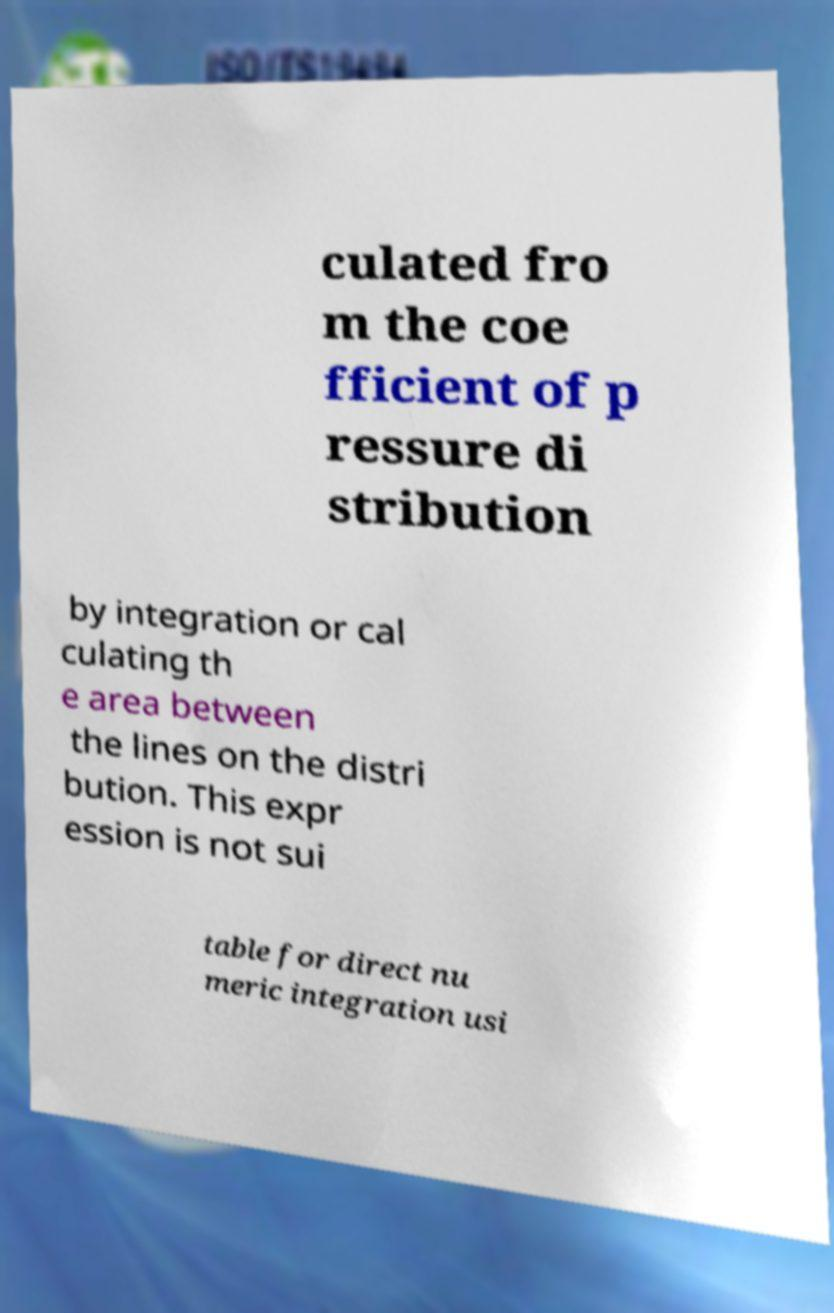Could you assist in decoding the text presented in this image and type it out clearly? culated fro m the coe fficient of p ressure di stribution by integration or cal culating th e area between the lines on the distri bution. This expr ession is not sui table for direct nu meric integration usi 